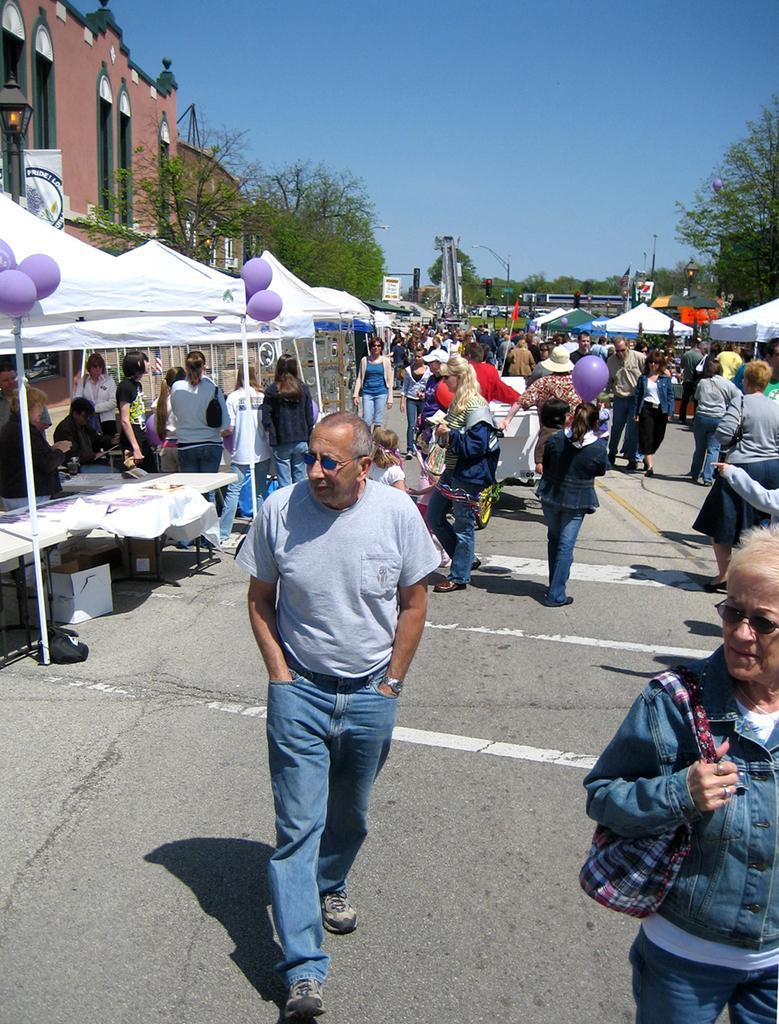Can you describe this image briefly? In the foreground of this image, there are persons walking on the road. On the left, there are white tents, balloons under which, there are persons sitting and standing and we can also see few buildings on the left. In the background, there are trees, poles, boards and the sky. 